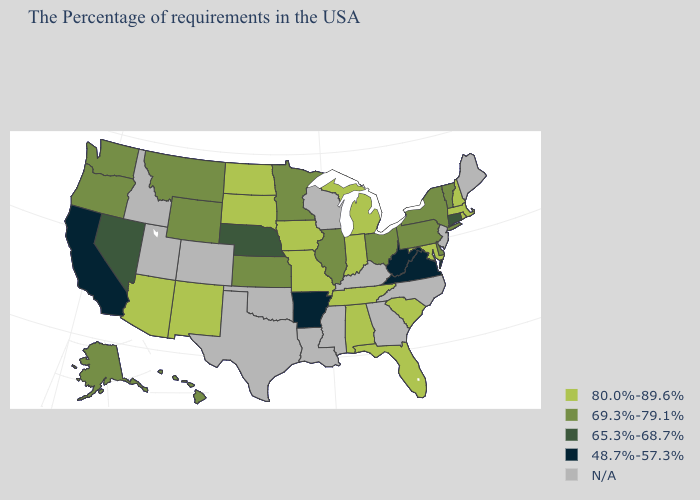What is the value of Idaho?
Answer briefly. N/A. Among the states that border Nevada , which have the lowest value?
Keep it brief. California. Which states have the lowest value in the West?
Concise answer only. California. What is the highest value in states that border Delaware?
Short answer required. 80.0%-89.6%. What is the value of Indiana?
Quick response, please. 80.0%-89.6%. Does Minnesota have the lowest value in the MidWest?
Concise answer only. No. What is the value of New York?
Be succinct. 69.3%-79.1%. Which states have the highest value in the USA?
Quick response, please. Massachusetts, Rhode Island, New Hampshire, Maryland, South Carolina, Florida, Michigan, Indiana, Alabama, Tennessee, Missouri, Iowa, South Dakota, North Dakota, New Mexico, Arizona. Among the states that border Nevada , which have the highest value?
Keep it brief. Arizona. Name the states that have a value in the range 69.3%-79.1%?
Answer briefly. Vermont, New York, Delaware, Pennsylvania, Ohio, Illinois, Minnesota, Kansas, Wyoming, Montana, Washington, Oregon, Alaska, Hawaii. What is the value of Wisconsin?
Give a very brief answer. N/A. Does South Carolina have the lowest value in the South?
Short answer required. No. Does Connecticut have the highest value in the USA?
Give a very brief answer. No. 